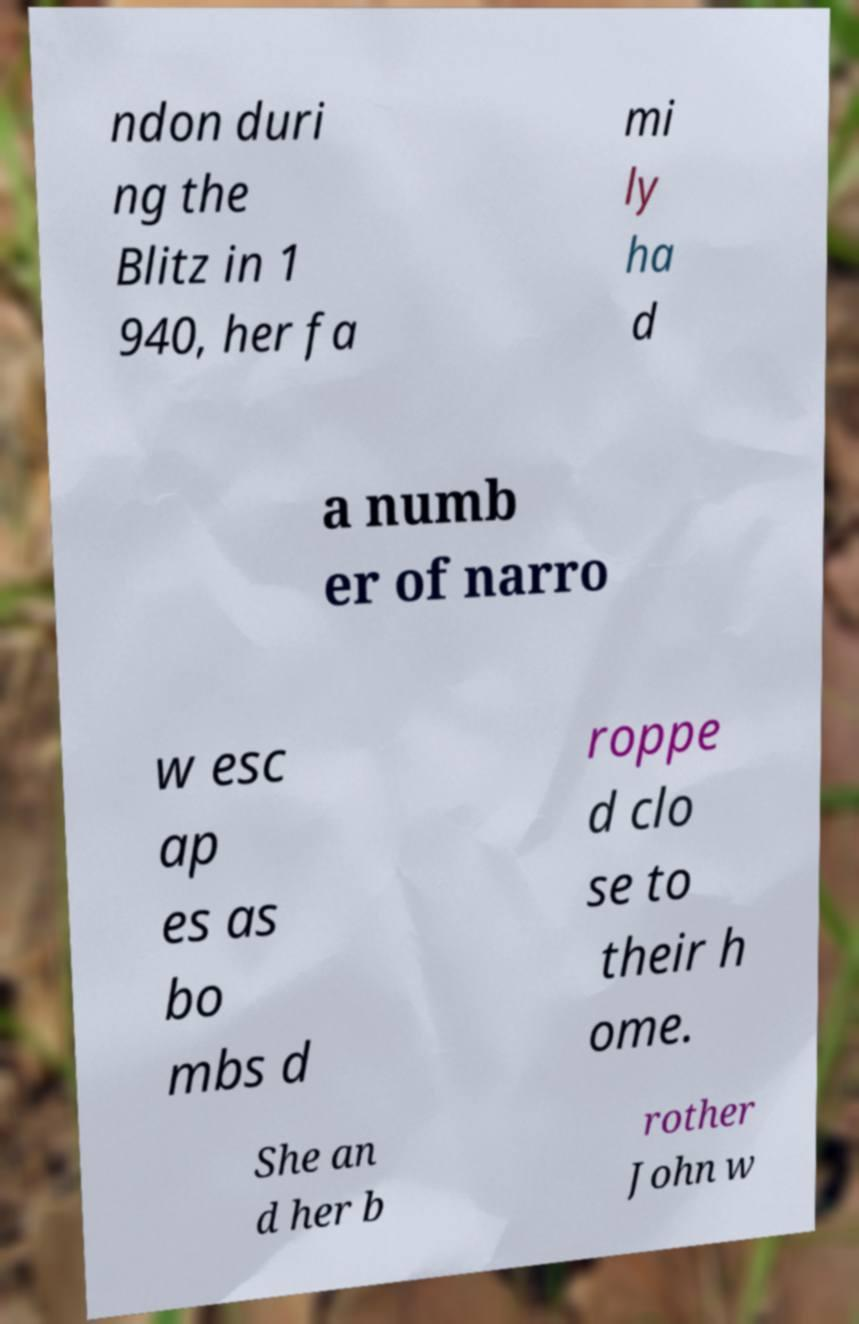What messages or text are displayed in this image? I need them in a readable, typed format. ndon duri ng the Blitz in 1 940, her fa mi ly ha d a numb er of narro w esc ap es as bo mbs d roppe d clo se to their h ome. She an d her b rother John w 